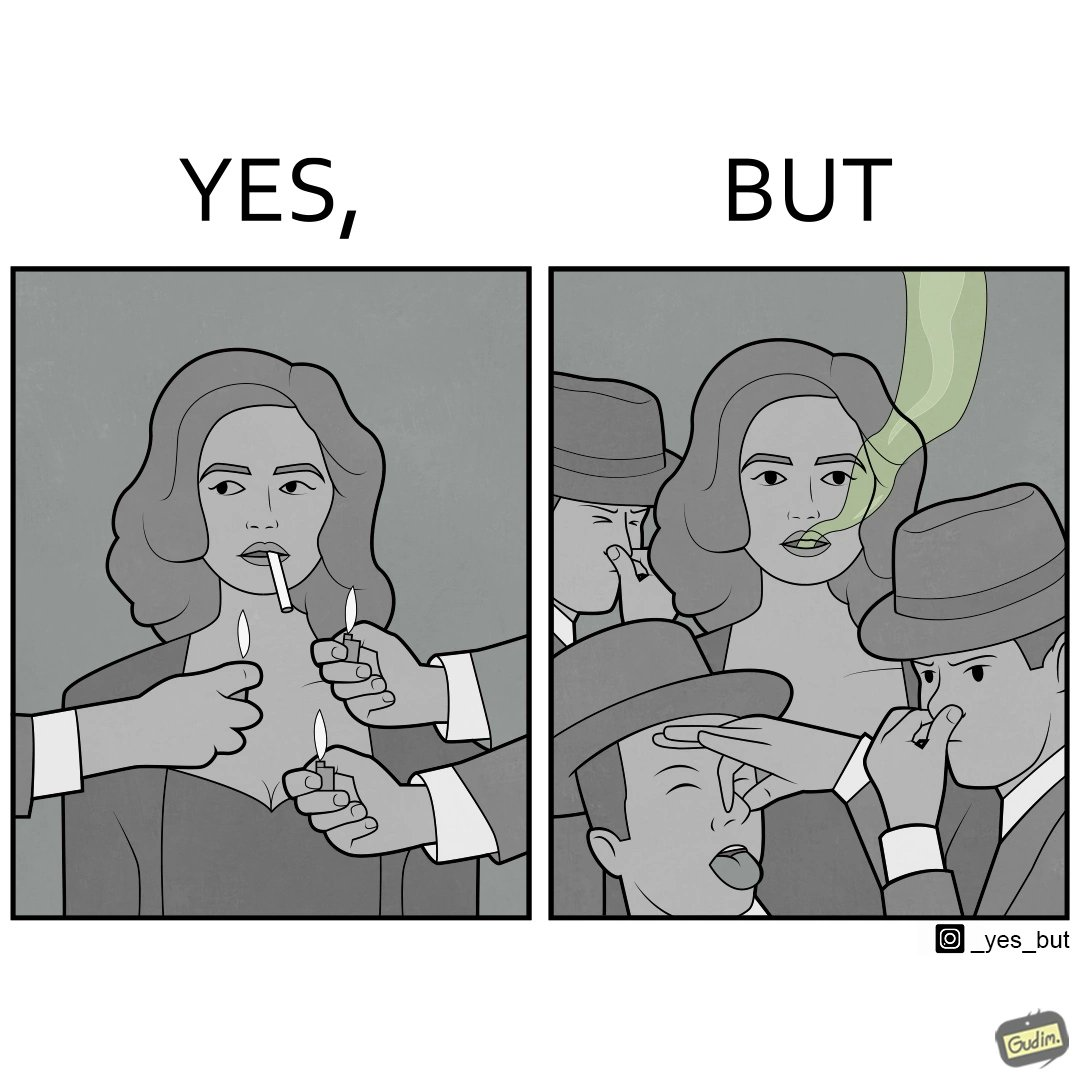What does this image depict? The image is ironical, as people seem to be holding lighters to light up a woman's cigarette at an attempt to probably  impress her, while showing that the very same people are holding their noses on account of what appears to be bad smell coming out of the woman's mouth. 